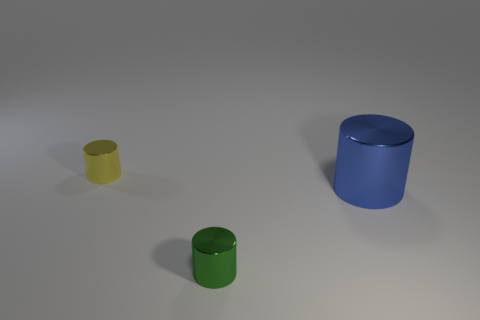Is the number of tiny yellow metal objects that are on the right side of the large cylinder less than the number of rubber cubes?
Your answer should be compact. No. Is the number of green metallic objects less than the number of large cyan shiny cylinders?
Your response must be concise. No. Are the big object and the small yellow cylinder made of the same material?
Give a very brief answer. Yes. What number of other things are there of the same size as the blue cylinder?
Give a very brief answer. 0. What is the color of the cylinder that is on the left side of the cylinder that is in front of the big cylinder?
Your answer should be compact. Yellow. Are there any other small green cylinders that have the same material as the small green cylinder?
Offer a terse response. No. There is a metal object to the right of the tiny thing in front of the tiny thing that is on the left side of the small green metal thing; what is its color?
Offer a terse response. Blue. How many purple rubber cylinders are there?
Ensure brevity in your answer.  0. There is another metallic thing that is the same size as the green metallic object; what is its color?
Your answer should be compact. Yellow. Do the tiny object in front of the yellow metallic cylinder and the yellow thing behind the tiny green metallic thing have the same material?
Your answer should be very brief. Yes. 